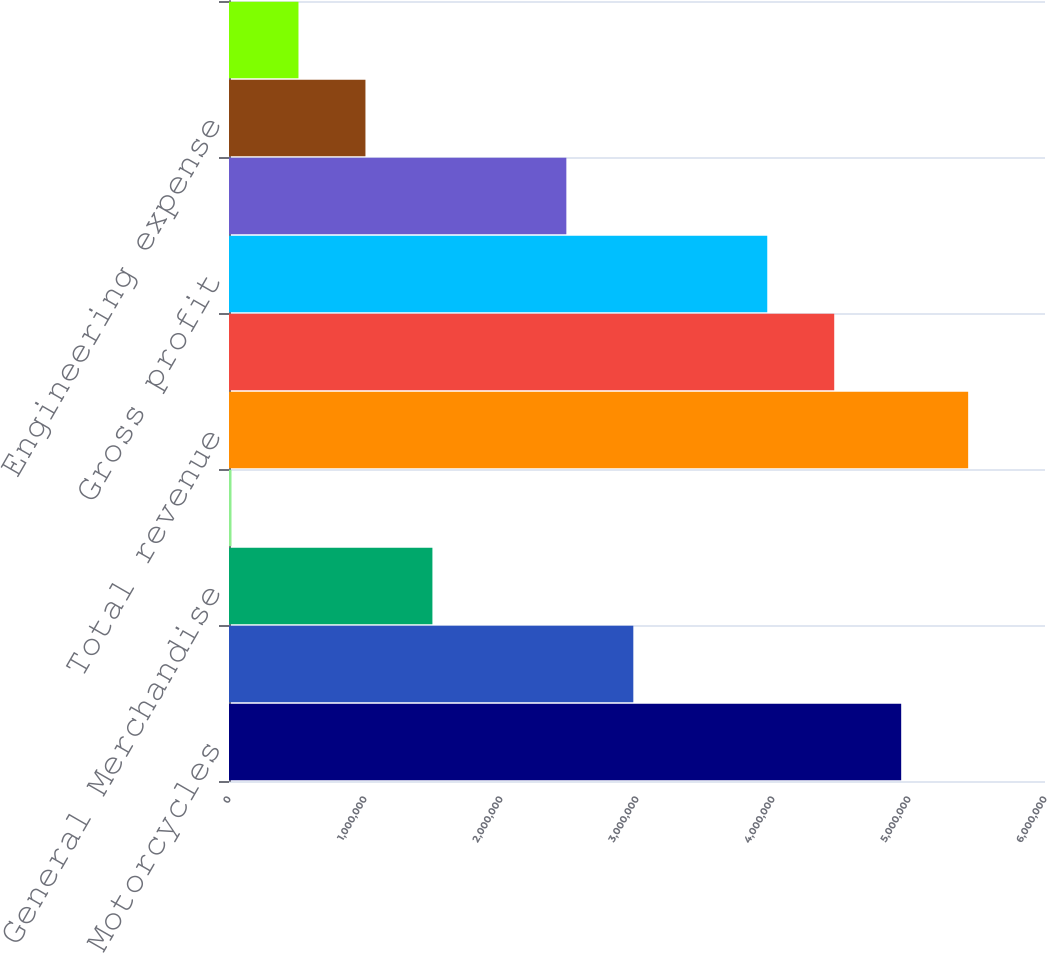Convert chart. <chart><loc_0><loc_0><loc_500><loc_500><bar_chart><fcel>Motorcycles<fcel>Parts & Accessories<fcel>General Merchandise<fcel>Other<fcel>Total revenue<fcel>Cost of goods sold<fcel>Gross profit<fcel>Selling & administrative<fcel>Engineering expense<fcel>Restructuring (benefit)<nl><fcel>4.94258e+06<fcel>2.97293e+06<fcel>1.49568e+06<fcel>18440<fcel>5.435e+06<fcel>4.45017e+06<fcel>3.95775e+06<fcel>2.48051e+06<fcel>1.00327e+06<fcel>510854<nl></chart> 